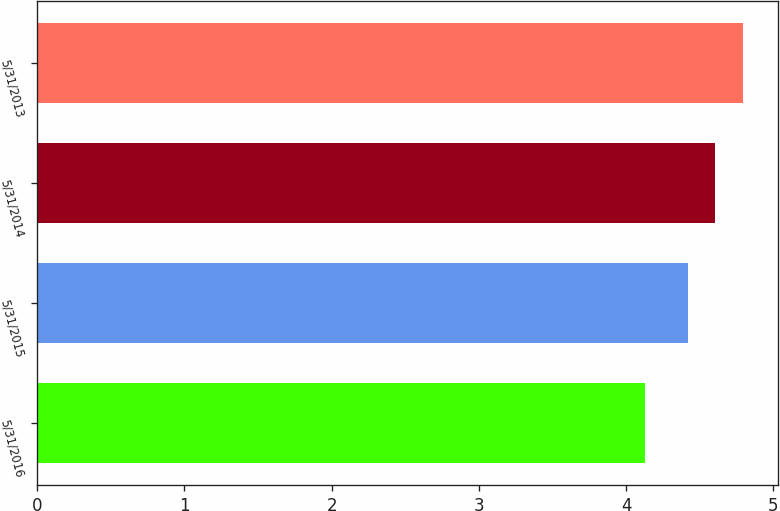Convert chart to OTSL. <chart><loc_0><loc_0><loc_500><loc_500><bar_chart><fcel>5/31/2016<fcel>5/31/2015<fcel>5/31/2014<fcel>5/31/2013<nl><fcel>4.13<fcel>4.42<fcel>4.6<fcel>4.79<nl></chart> 